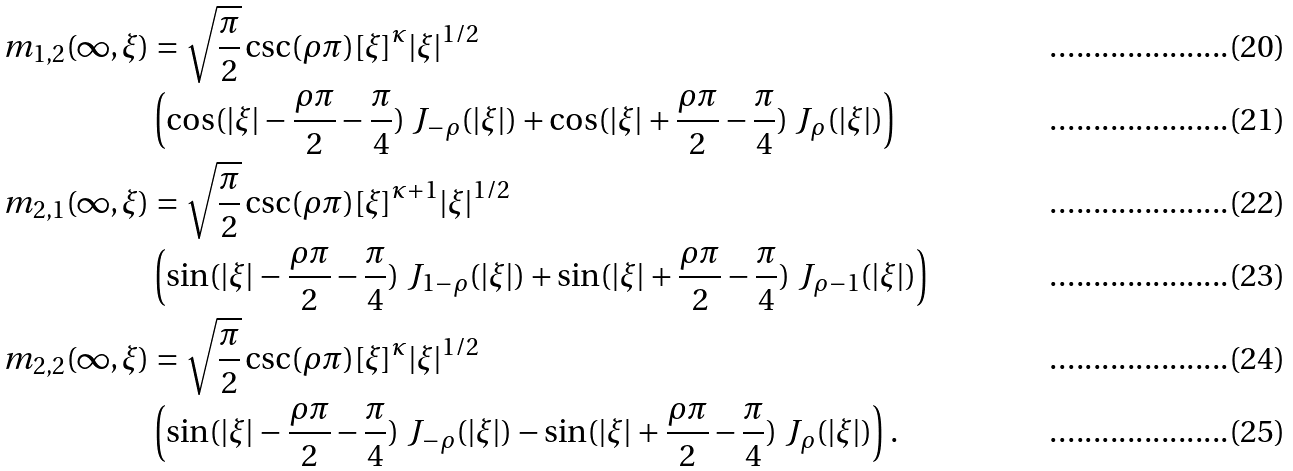<formula> <loc_0><loc_0><loc_500><loc_500>m _ { 1 , 2 } ( \infty , \xi ) & = \sqrt { \frac { \pi } { 2 } } \csc ( \rho \pi ) [ \xi ] ^ { \kappa } | \xi | ^ { 1 / 2 } \\ & \left ( \cos ( | \xi | - \frac { \rho \pi } 2 - \frac { \pi } { 4 } ) \ J _ { - \rho } ( | \xi | ) + \cos ( | \xi | + \frac { \rho \pi } 2 - \frac { \pi } { 4 } ) \ J _ { \rho } ( | \xi | ) \right ) \\ m _ { 2 , 1 } ( \infty , \xi ) & = \sqrt { \frac { \pi } { 2 } } \csc ( \rho \pi ) [ \xi ] ^ { \kappa + 1 } | \xi | ^ { 1 / 2 } \\ & \left ( \sin ( | \xi | - \frac { \rho \pi } 2 - \frac { \pi } { 4 } ) \ J _ { 1 - \rho } ( | \xi | ) + \sin ( | \xi | + \frac { \rho \pi } 2 - \frac { \pi } { 4 } ) \ J _ { \rho - 1 } ( | \xi | ) \right ) \\ m _ { 2 , 2 } ( \infty , \xi ) & = \sqrt { \frac { \pi } { 2 } } \csc ( \rho \pi ) [ \xi ] ^ { \kappa } | \xi | ^ { 1 / 2 } \\ & \left ( \sin ( | \xi | - \frac { \rho \pi } 2 - \frac { \pi } { 4 } ) \ J _ { - \rho } ( | \xi | ) - \sin ( | \xi | + \frac { \rho \pi } 2 - \frac { \pi } { 4 } ) \ J _ { \rho } ( | \xi | ) \right ) .</formula> 